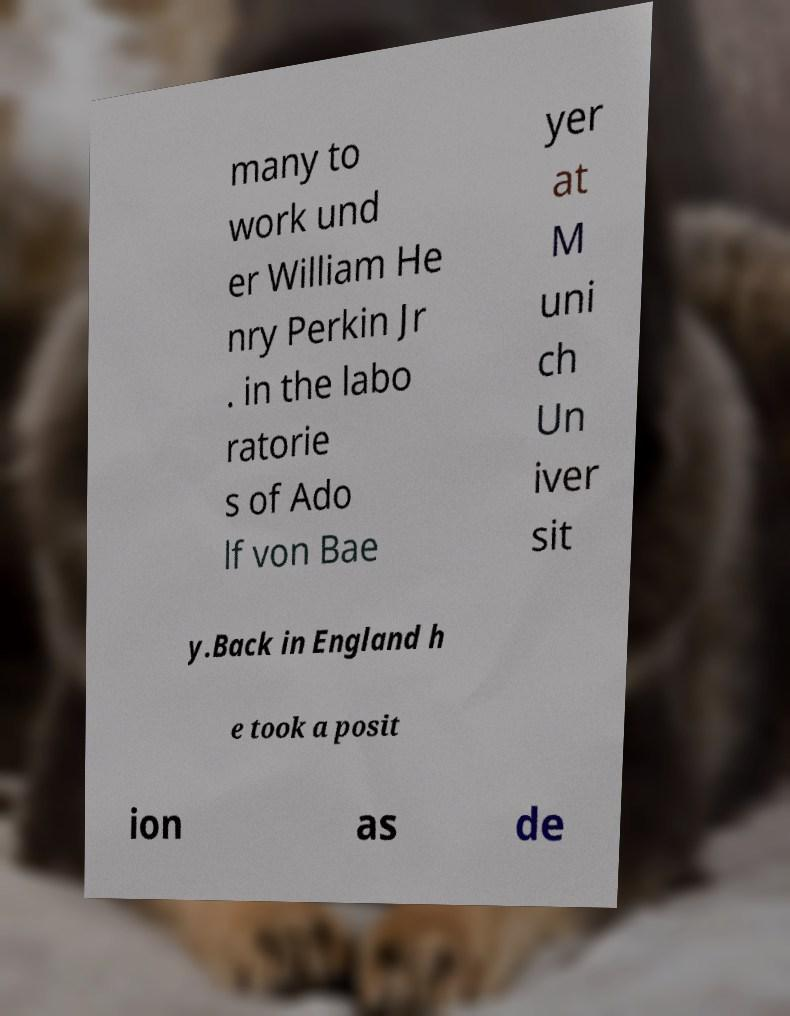I need the written content from this picture converted into text. Can you do that? many to work und er William He nry Perkin Jr . in the labo ratorie s of Ado lf von Bae yer at M uni ch Un iver sit y.Back in England h e took a posit ion as de 